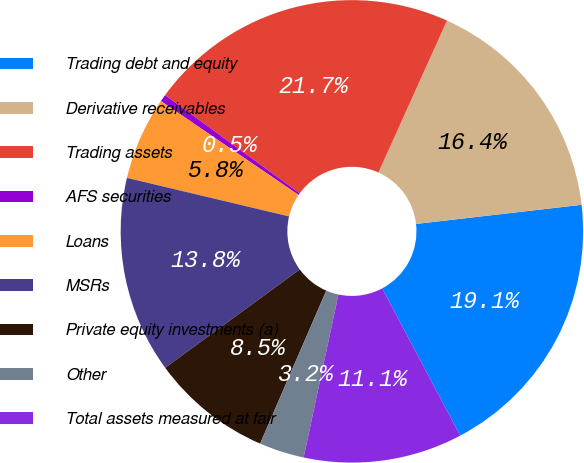Convert chart. <chart><loc_0><loc_0><loc_500><loc_500><pie_chart><fcel>Trading debt and equity<fcel>Derivative receivables<fcel>Trading assets<fcel>AFS securities<fcel>Loans<fcel>MSRs<fcel>Private equity investments (a)<fcel>Other<fcel>Total assets measured at fair<nl><fcel>19.07%<fcel>16.42%<fcel>21.72%<fcel>0.5%<fcel>5.81%<fcel>13.76%<fcel>8.46%<fcel>3.15%<fcel>11.11%<nl></chart> 